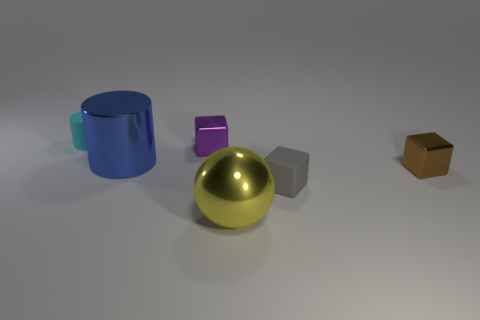Are there any other things that are the same size as the cyan matte cylinder?
Provide a succinct answer. Yes. What is the color of the cylinder that is the same material as the yellow object?
Keep it short and to the point. Blue. Does the large yellow thing have the same shape as the big blue thing?
Keep it short and to the point. No. What number of tiny blocks are both behind the blue metal thing and in front of the tiny brown metal thing?
Your answer should be very brief. 0. What number of metallic objects are gray things or small things?
Your response must be concise. 2. What size is the matte thing right of the cylinder behind the metal cylinder?
Ensure brevity in your answer.  Small. There is a tiny metal cube that is left of the small matte thing that is to the right of the tiny cyan matte cylinder; are there any cylinders in front of it?
Give a very brief answer. Yes. Does the big object in front of the tiny brown metal thing have the same material as the blue cylinder on the left side of the small purple block?
Ensure brevity in your answer.  Yes. What number of objects are blue rubber spheres or metal cubes on the left side of the small matte cube?
Give a very brief answer. 1. What number of other gray matte things are the same shape as the small gray rubber thing?
Offer a terse response. 0. 